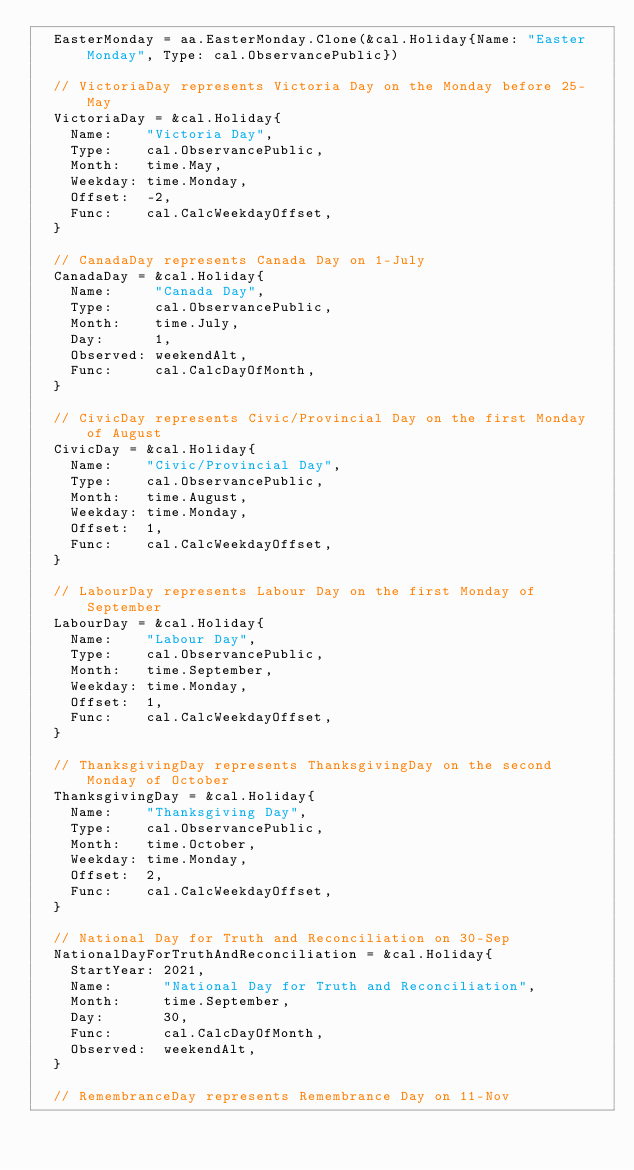Convert code to text. <code><loc_0><loc_0><loc_500><loc_500><_Go_>	EasterMonday = aa.EasterMonday.Clone(&cal.Holiday{Name: "Easter Monday", Type: cal.ObservancePublic})

	// VictoriaDay represents Victoria Day on the Monday before 25-May
	VictoriaDay = &cal.Holiday{
		Name:    "Victoria Day",
		Type:    cal.ObservancePublic,
		Month:   time.May,
		Weekday: time.Monday,
		Offset:  -2,
		Func:    cal.CalcWeekdayOffset,
	}

	// CanadaDay represents Canada Day on 1-July
	CanadaDay = &cal.Holiday{
		Name:     "Canada Day",
		Type:     cal.ObservancePublic,
		Month:    time.July,
		Day:      1,
		Observed: weekendAlt,
		Func:     cal.CalcDayOfMonth,
	}

	// CivicDay represents Civic/Provincial Day on the first Monday of August
	CivicDay = &cal.Holiday{
		Name:    "Civic/Provincial Day",
		Type:    cal.ObservancePublic,
		Month:   time.August,
		Weekday: time.Monday,
		Offset:  1,
		Func:    cal.CalcWeekdayOffset,
	}

	// LabourDay represents Labour Day on the first Monday of September
	LabourDay = &cal.Holiday{
		Name:    "Labour Day",
		Type:    cal.ObservancePublic,
		Month:   time.September,
		Weekday: time.Monday,
		Offset:  1,
		Func:    cal.CalcWeekdayOffset,
	}

	// ThanksgivingDay represents ThanksgivingDay on the second Monday of October
	ThanksgivingDay = &cal.Holiday{
		Name:    "Thanksgiving Day",
		Type:    cal.ObservancePublic,
		Month:   time.October,
		Weekday: time.Monday,
		Offset:  2,
		Func:    cal.CalcWeekdayOffset,
	}

	// National Day for Truth and Reconciliation on 30-Sep
	NationalDayForTruthAndReconciliation = &cal.Holiday{
		StartYear: 2021,
		Name:      "National Day for Truth and Reconciliation",
		Month:     time.September,
		Day:       30,
		Func:      cal.CalcDayOfMonth,
		Observed:  weekendAlt,
	}

	// RemembranceDay represents Remembrance Day on 11-Nov</code> 